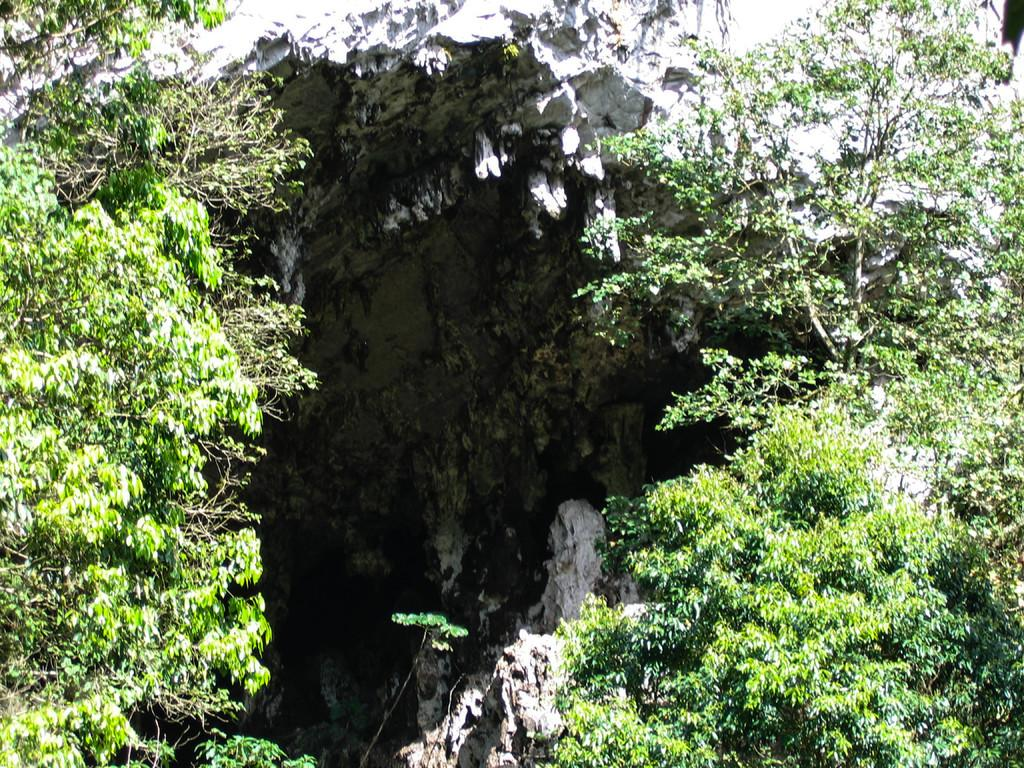What type of vegetation can be seen in the image? There are trees in the image. What geological feature is present in the image? There is a rock in the image. What type of horn can be seen on the trees in the image? There are no horns present on the trees in the image. What type of yam is growing near the rock in the image? There are no yams present in the image. 